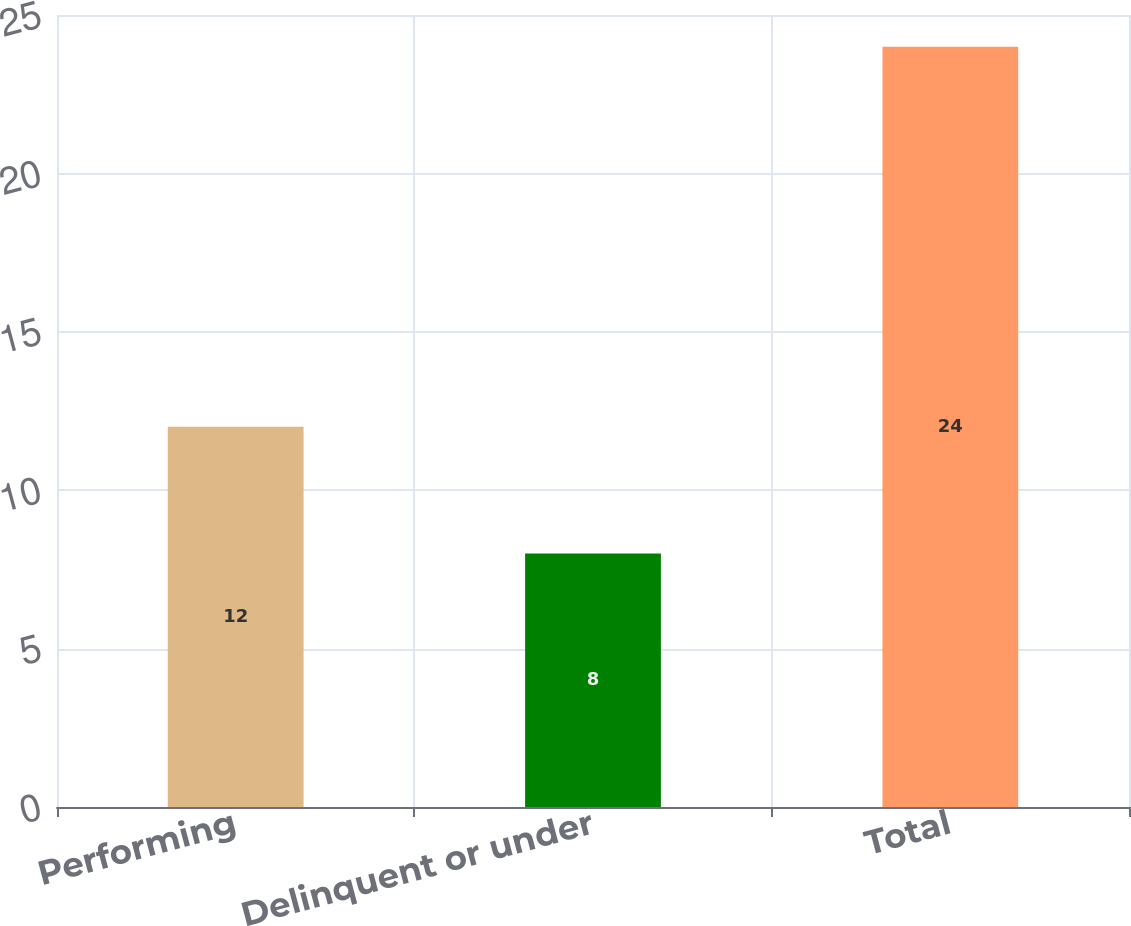Convert chart. <chart><loc_0><loc_0><loc_500><loc_500><bar_chart><fcel>Performing<fcel>Delinquent or under<fcel>Total<nl><fcel>12<fcel>8<fcel>24<nl></chart> 